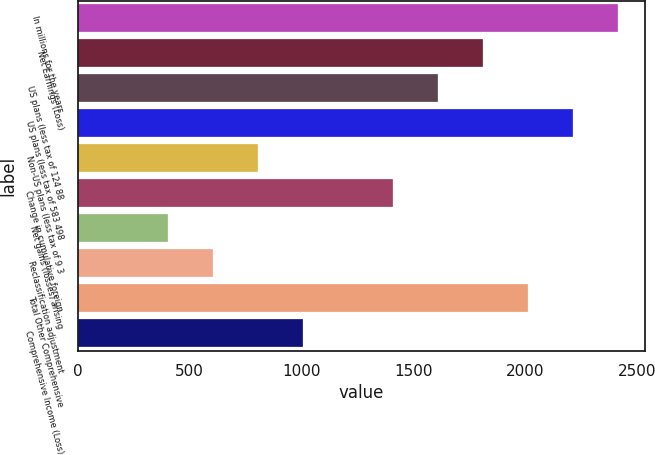Convert chart. <chart><loc_0><loc_0><loc_500><loc_500><bar_chart><fcel>In millions for the years<fcel>Net Earnings (Loss)<fcel>US plans (less tax of 124 88<fcel>US plans (less tax of 583 498<fcel>Non-US plans (less tax of 9 3<fcel>Change in cumulative foreign<fcel>Net gains (losses) arising<fcel>Reclassification adjustment<fcel>Total Other Comprehensive<fcel>Comprehensive Income (Loss)<nl><fcel>2413.8<fcel>1811.1<fcel>1610.2<fcel>2212.9<fcel>806.6<fcel>1409.3<fcel>404.8<fcel>605.7<fcel>2012<fcel>1007.5<nl></chart> 